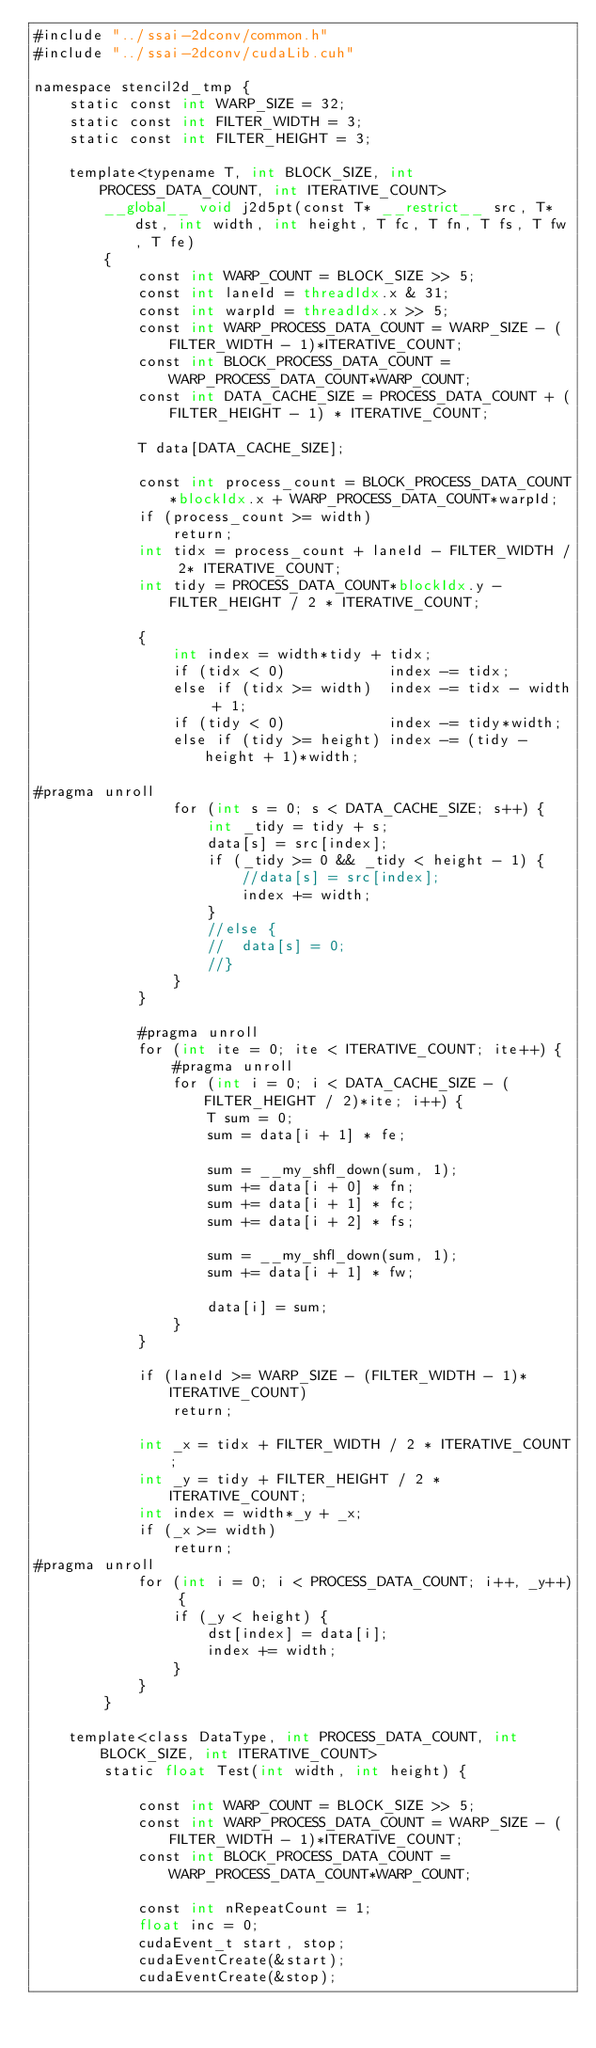<code> <loc_0><loc_0><loc_500><loc_500><_Cuda_>#include "../ssai-2dconv/common.h"
#include "../ssai-2dconv/cudaLib.cuh"

namespace stencil2d_tmp {
	static const int WARP_SIZE = 32;
	static const int FILTER_WIDTH = 3;
	static const int FILTER_HEIGHT = 3;

	template<typename T, int BLOCK_SIZE, int PROCESS_DATA_COUNT, int ITERATIVE_COUNT>
		__global__ void j2d5pt(const T* __restrict__ src, T* dst, int width, int height, T fc, T fn, T fs, T fw, T fe) 
		{
			const int WARP_COUNT = BLOCK_SIZE >> 5;
			const int laneId = threadIdx.x & 31;
			const int warpId = threadIdx.x >> 5;
			const int WARP_PROCESS_DATA_COUNT = WARP_SIZE - (FILTER_WIDTH - 1)*ITERATIVE_COUNT;
			const int BLOCK_PROCESS_DATA_COUNT = WARP_PROCESS_DATA_COUNT*WARP_COUNT;
			const int DATA_CACHE_SIZE = PROCESS_DATA_COUNT + (FILTER_HEIGHT - 1) * ITERATIVE_COUNT;

			T data[DATA_CACHE_SIZE];

			const int process_count = BLOCK_PROCESS_DATA_COUNT*blockIdx.x + WARP_PROCESS_DATA_COUNT*warpId;
			if (process_count >= width)
				return;
			int tidx = process_count + laneId - FILTER_WIDTH / 2* ITERATIVE_COUNT;
			int tidy = PROCESS_DATA_COUNT*blockIdx.y - FILTER_HEIGHT / 2 * ITERATIVE_COUNT;

			{
				int index = width*tidy + tidx;
				if (tidx < 0)            index -= tidx;
				else if (tidx >= width)  index -= tidx - width + 1;
				if (tidy < 0)            index -= tidy*width;
				else if (tidy >= height) index -= (tidy - height + 1)*width;

#pragma unroll
				for (int s = 0; s < DATA_CACHE_SIZE; s++) {
					int _tidy = tidy + s;
					data[s] = src[index];
					if (_tidy >= 0 && _tidy < height - 1) {
						//data[s] = src[index];
						index += width;
					}
					//else {
					//	data[s] = 0;
					//}
				}
			}

			#pragma unroll
			for (int ite = 0; ite < ITERATIVE_COUNT; ite++) {
				#pragma unroll
				for (int i = 0; i < DATA_CACHE_SIZE - (FILTER_HEIGHT / 2)*ite; i++) {
					T sum = 0;
					sum = data[i + 1] * fe;

					sum = __my_shfl_down(sum, 1);
					sum += data[i + 0] * fn;
					sum += data[i + 1] * fc;
					sum += data[i + 2] * fs;

					sum = __my_shfl_down(sum, 1);
					sum += data[i + 1] * fw;

					data[i] = sum;
				}
			}

			if (laneId >= WARP_SIZE - (FILTER_WIDTH - 1)*ITERATIVE_COUNT)
				return;

			int _x = tidx + FILTER_WIDTH / 2 * ITERATIVE_COUNT;
			int _y = tidy + FILTER_HEIGHT / 2 * ITERATIVE_COUNT;
			int index = width*_y + _x;
			if (_x >= width)
				return;
#pragma unroll
			for (int i = 0; i < PROCESS_DATA_COUNT; i++, _y++) {
				if (_y < height) {
					dst[index] = data[i];
					index += width;
				}
			}
		}

	template<class DataType, int PROCESS_DATA_COUNT, int BLOCK_SIZE, int ITERATIVE_COUNT>
		static float Test(int width, int height) {

			const int WARP_COUNT = BLOCK_SIZE >> 5;
			const int WARP_PROCESS_DATA_COUNT = WARP_SIZE - (FILTER_WIDTH - 1)*ITERATIVE_COUNT;
			const int BLOCK_PROCESS_DATA_COUNT = WARP_PROCESS_DATA_COUNT*WARP_COUNT;

			const int nRepeatCount = 1;
			float inc = 0;
			cudaEvent_t start, stop;
			cudaEventCreate(&start);
			cudaEventCreate(&stop);
</code> 